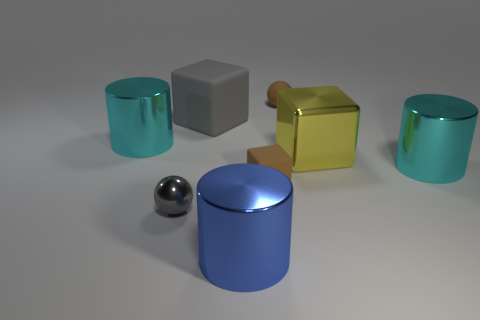Subtract all big yellow metal blocks. How many blocks are left? 2 Subtract all blue spheres. How many cyan cylinders are left? 2 Subtract 1 blocks. How many blocks are left? 2 Add 2 small blocks. How many objects exist? 10 Subtract all cylinders. How many objects are left? 5 Subtract all gray cylinders. Subtract all red blocks. How many cylinders are left? 3 Add 6 large yellow cubes. How many large yellow cubes are left? 7 Add 5 tiny purple matte cylinders. How many tiny purple matte cylinders exist? 5 Subtract 0 blue blocks. How many objects are left? 8 Subtract all tiny cyan rubber spheres. Subtract all blue objects. How many objects are left? 7 